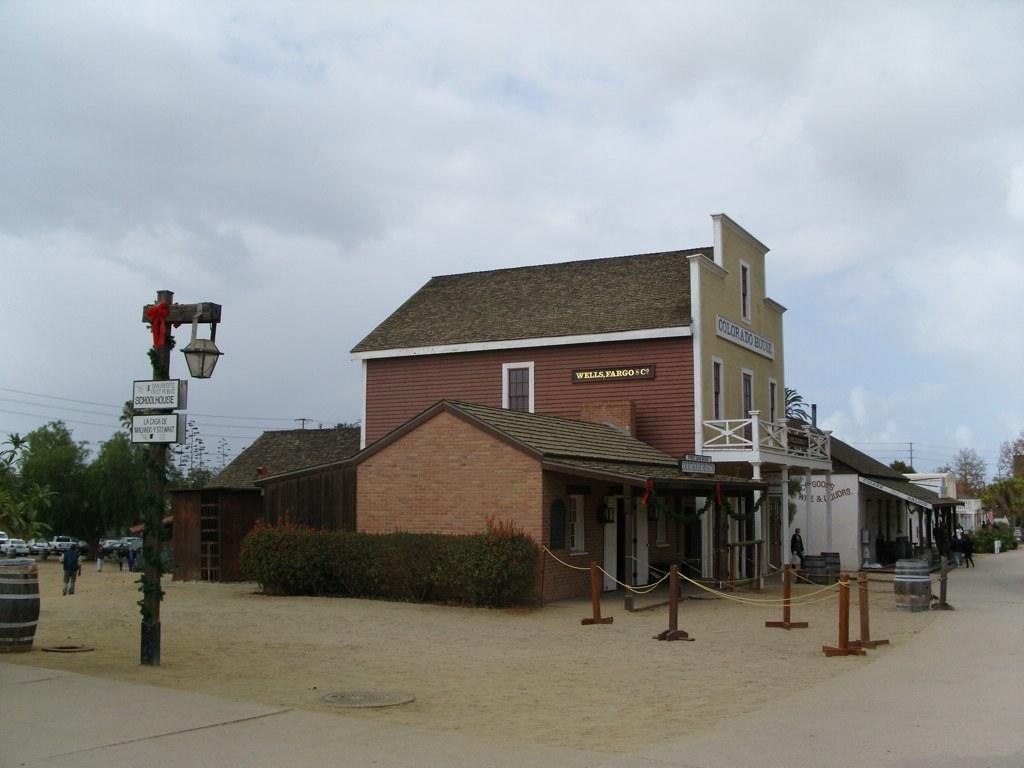How would you summarize this image in a sentence or two? In this picture I can see vehicles, there are barrels, boards, there are group of people standing, there are plants, trees, there are buildings, and in the background there is the sky. 